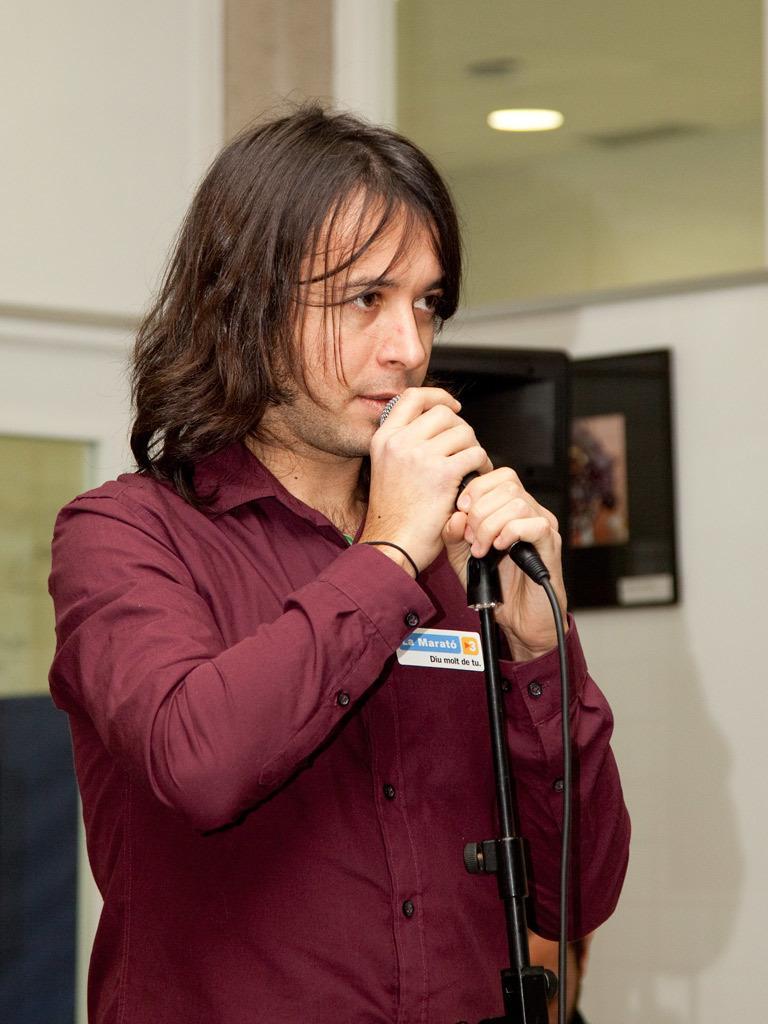In one or two sentences, can you explain what this image depicts? This image is clicked in a room. There is a man standing and talking in a mic. He is wearing brown shirt. In the background there is a wall. 